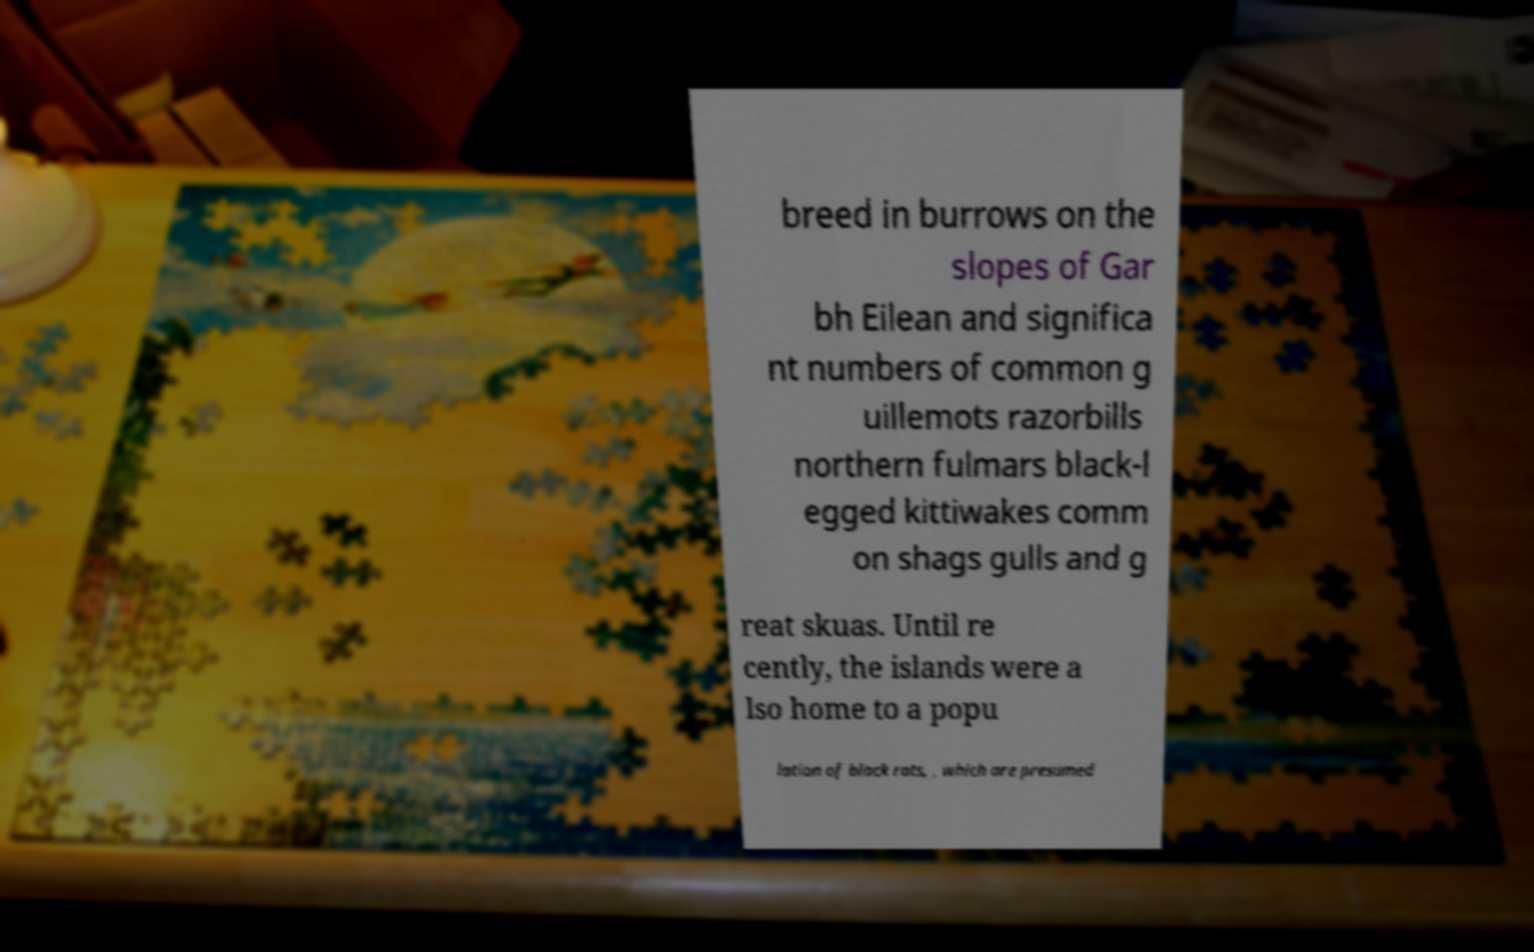Can you read and provide the text displayed in the image?This photo seems to have some interesting text. Can you extract and type it out for me? breed in burrows on the slopes of Gar bh Eilean and significa nt numbers of common g uillemots razorbills northern fulmars black-l egged kittiwakes comm on shags gulls and g reat skuas. Until re cently, the islands were a lso home to a popu lation of black rats, , which are presumed 